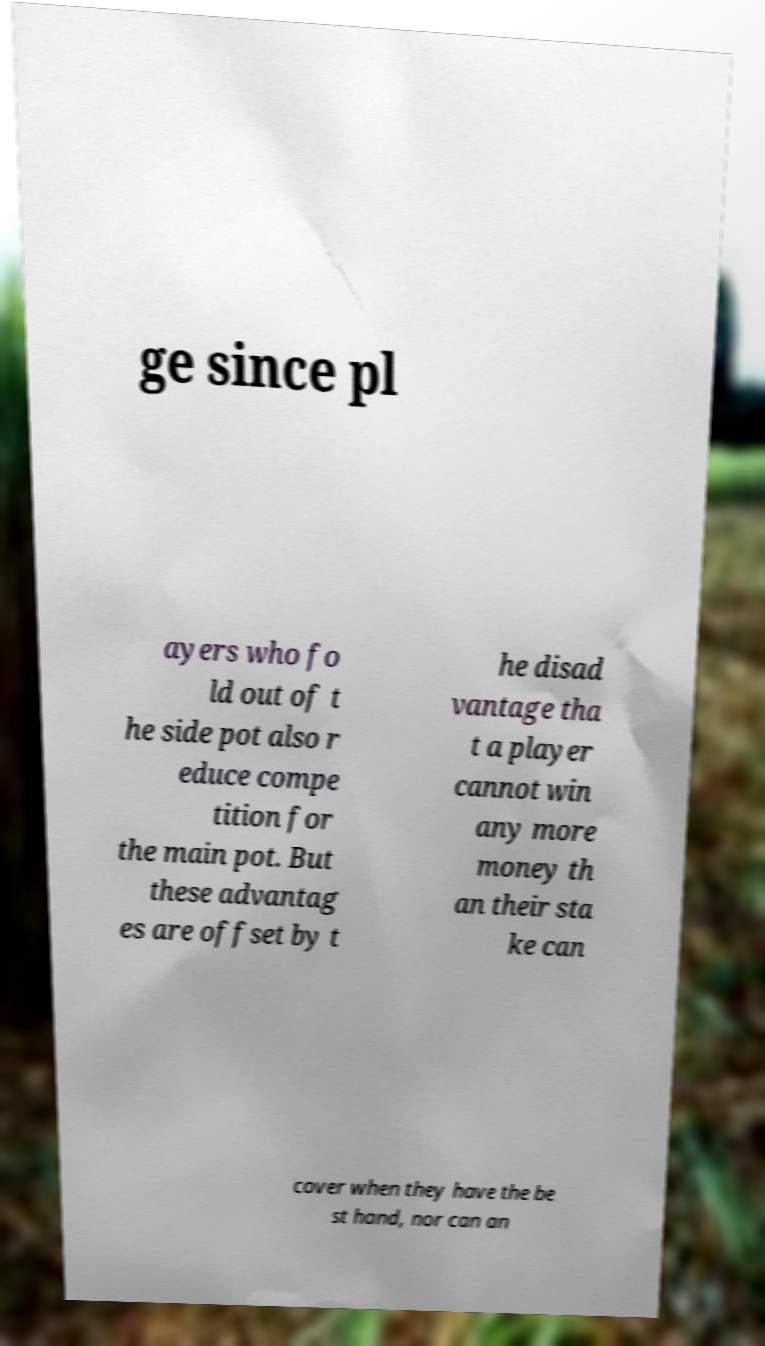Could you assist in decoding the text presented in this image and type it out clearly? ge since pl ayers who fo ld out of t he side pot also r educe compe tition for the main pot. But these advantag es are offset by t he disad vantage tha t a player cannot win any more money th an their sta ke can cover when they have the be st hand, nor can an 